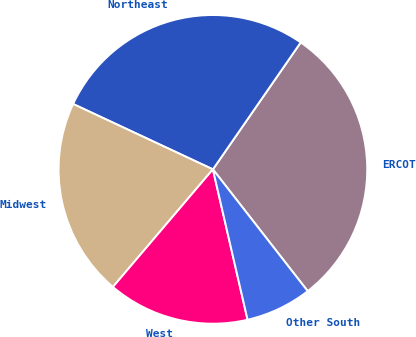Convert chart. <chart><loc_0><loc_0><loc_500><loc_500><pie_chart><fcel>ERCOT<fcel>Northeast<fcel>Midwest<fcel>West<fcel>Other South<nl><fcel>29.84%<fcel>27.67%<fcel>20.75%<fcel>14.82%<fcel>6.92%<nl></chart> 